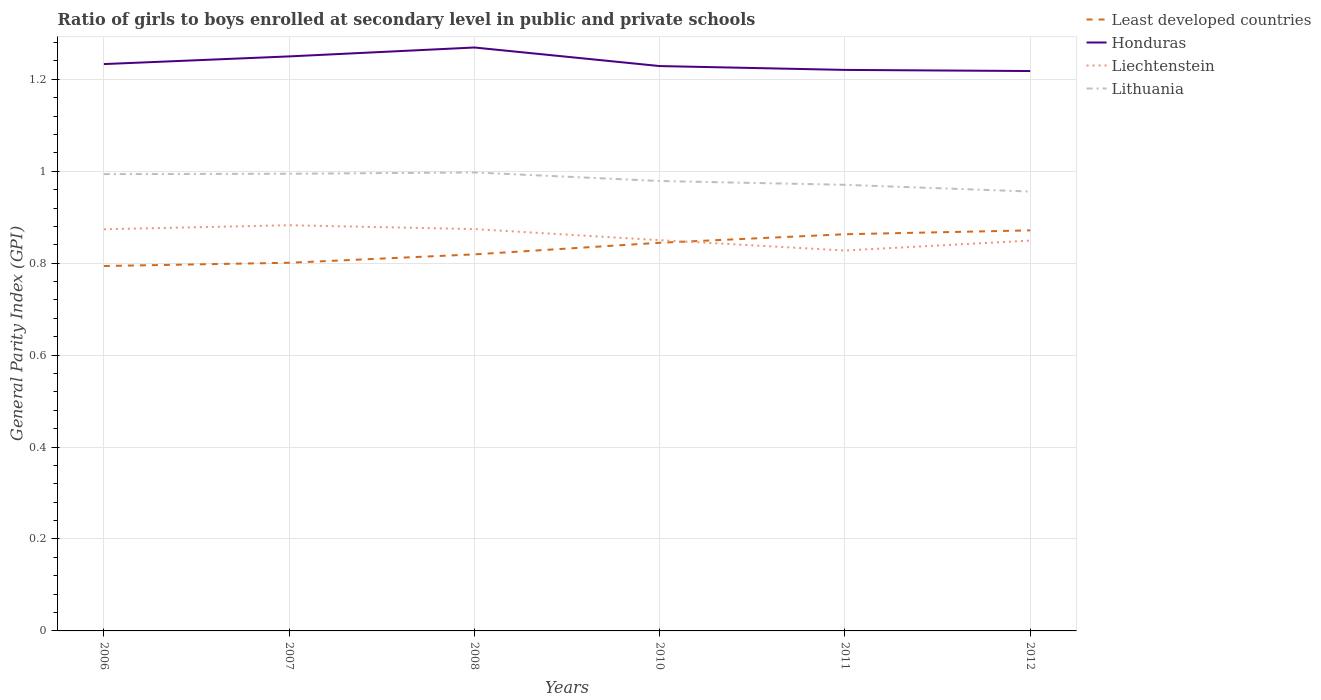How many different coloured lines are there?
Provide a short and direct response. 4. Does the line corresponding to Lithuania intersect with the line corresponding to Honduras?
Your answer should be compact. No. Is the number of lines equal to the number of legend labels?
Offer a terse response. Yes. Across all years, what is the maximum general parity index in Least developed countries?
Your answer should be very brief. 0.79. In which year was the general parity index in Least developed countries maximum?
Your answer should be compact. 2006. What is the total general parity index in Liechtenstein in the graph?
Your response must be concise. 0.02. What is the difference between the highest and the second highest general parity index in Least developed countries?
Provide a succinct answer. 0.08. What is the difference between the highest and the lowest general parity index in Lithuania?
Your answer should be compact. 3. Are the values on the major ticks of Y-axis written in scientific E-notation?
Your answer should be compact. No. Does the graph contain any zero values?
Provide a short and direct response. No. Does the graph contain grids?
Make the answer very short. Yes. Where does the legend appear in the graph?
Give a very brief answer. Top right. What is the title of the graph?
Offer a very short reply. Ratio of girls to boys enrolled at secondary level in public and private schools. Does "Turkmenistan" appear as one of the legend labels in the graph?
Offer a terse response. No. What is the label or title of the Y-axis?
Provide a short and direct response. General Parity Index (GPI). What is the General Parity Index (GPI) in Least developed countries in 2006?
Provide a short and direct response. 0.79. What is the General Parity Index (GPI) in Honduras in 2006?
Offer a terse response. 1.23. What is the General Parity Index (GPI) in Liechtenstein in 2006?
Keep it short and to the point. 0.87. What is the General Parity Index (GPI) in Lithuania in 2006?
Offer a terse response. 0.99. What is the General Parity Index (GPI) of Least developed countries in 2007?
Provide a succinct answer. 0.8. What is the General Parity Index (GPI) in Honduras in 2007?
Your answer should be very brief. 1.25. What is the General Parity Index (GPI) of Liechtenstein in 2007?
Give a very brief answer. 0.88. What is the General Parity Index (GPI) of Lithuania in 2007?
Ensure brevity in your answer.  0.99. What is the General Parity Index (GPI) in Least developed countries in 2008?
Ensure brevity in your answer.  0.82. What is the General Parity Index (GPI) in Honduras in 2008?
Your answer should be very brief. 1.27. What is the General Parity Index (GPI) of Liechtenstein in 2008?
Your response must be concise. 0.87. What is the General Parity Index (GPI) of Lithuania in 2008?
Offer a very short reply. 1. What is the General Parity Index (GPI) in Least developed countries in 2010?
Provide a succinct answer. 0.84. What is the General Parity Index (GPI) of Honduras in 2010?
Provide a succinct answer. 1.23. What is the General Parity Index (GPI) of Liechtenstein in 2010?
Give a very brief answer. 0.85. What is the General Parity Index (GPI) in Lithuania in 2010?
Keep it short and to the point. 0.98. What is the General Parity Index (GPI) in Least developed countries in 2011?
Keep it short and to the point. 0.86. What is the General Parity Index (GPI) in Honduras in 2011?
Give a very brief answer. 1.22. What is the General Parity Index (GPI) of Liechtenstein in 2011?
Your response must be concise. 0.83. What is the General Parity Index (GPI) in Lithuania in 2011?
Ensure brevity in your answer.  0.97. What is the General Parity Index (GPI) in Least developed countries in 2012?
Provide a short and direct response. 0.87. What is the General Parity Index (GPI) in Honduras in 2012?
Offer a very short reply. 1.22. What is the General Parity Index (GPI) of Liechtenstein in 2012?
Ensure brevity in your answer.  0.85. What is the General Parity Index (GPI) in Lithuania in 2012?
Give a very brief answer. 0.96. Across all years, what is the maximum General Parity Index (GPI) of Least developed countries?
Ensure brevity in your answer.  0.87. Across all years, what is the maximum General Parity Index (GPI) of Honduras?
Your answer should be very brief. 1.27. Across all years, what is the maximum General Parity Index (GPI) of Liechtenstein?
Give a very brief answer. 0.88. Across all years, what is the maximum General Parity Index (GPI) of Lithuania?
Give a very brief answer. 1. Across all years, what is the minimum General Parity Index (GPI) of Least developed countries?
Provide a succinct answer. 0.79. Across all years, what is the minimum General Parity Index (GPI) in Honduras?
Your response must be concise. 1.22. Across all years, what is the minimum General Parity Index (GPI) of Liechtenstein?
Provide a succinct answer. 0.83. Across all years, what is the minimum General Parity Index (GPI) of Lithuania?
Your answer should be compact. 0.96. What is the total General Parity Index (GPI) in Least developed countries in the graph?
Provide a succinct answer. 4.99. What is the total General Parity Index (GPI) in Honduras in the graph?
Your response must be concise. 7.42. What is the total General Parity Index (GPI) of Liechtenstein in the graph?
Your response must be concise. 5.16. What is the total General Parity Index (GPI) in Lithuania in the graph?
Your response must be concise. 5.89. What is the difference between the General Parity Index (GPI) in Least developed countries in 2006 and that in 2007?
Offer a very short reply. -0.01. What is the difference between the General Parity Index (GPI) in Honduras in 2006 and that in 2007?
Your answer should be compact. -0.02. What is the difference between the General Parity Index (GPI) of Liechtenstein in 2006 and that in 2007?
Your answer should be very brief. -0.01. What is the difference between the General Parity Index (GPI) in Lithuania in 2006 and that in 2007?
Make the answer very short. -0. What is the difference between the General Parity Index (GPI) of Least developed countries in 2006 and that in 2008?
Offer a very short reply. -0.03. What is the difference between the General Parity Index (GPI) of Honduras in 2006 and that in 2008?
Provide a succinct answer. -0.04. What is the difference between the General Parity Index (GPI) of Liechtenstein in 2006 and that in 2008?
Make the answer very short. -0. What is the difference between the General Parity Index (GPI) in Lithuania in 2006 and that in 2008?
Give a very brief answer. -0. What is the difference between the General Parity Index (GPI) of Least developed countries in 2006 and that in 2010?
Your answer should be compact. -0.05. What is the difference between the General Parity Index (GPI) of Honduras in 2006 and that in 2010?
Keep it short and to the point. 0. What is the difference between the General Parity Index (GPI) in Liechtenstein in 2006 and that in 2010?
Make the answer very short. 0.02. What is the difference between the General Parity Index (GPI) of Lithuania in 2006 and that in 2010?
Offer a very short reply. 0.01. What is the difference between the General Parity Index (GPI) of Least developed countries in 2006 and that in 2011?
Provide a succinct answer. -0.07. What is the difference between the General Parity Index (GPI) in Honduras in 2006 and that in 2011?
Your answer should be compact. 0.01. What is the difference between the General Parity Index (GPI) in Liechtenstein in 2006 and that in 2011?
Keep it short and to the point. 0.05. What is the difference between the General Parity Index (GPI) in Lithuania in 2006 and that in 2011?
Your answer should be very brief. 0.02. What is the difference between the General Parity Index (GPI) of Least developed countries in 2006 and that in 2012?
Give a very brief answer. -0.08. What is the difference between the General Parity Index (GPI) of Honduras in 2006 and that in 2012?
Provide a succinct answer. 0.02. What is the difference between the General Parity Index (GPI) of Liechtenstein in 2006 and that in 2012?
Provide a short and direct response. 0.02. What is the difference between the General Parity Index (GPI) of Lithuania in 2006 and that in 2012?
Provide a succinct answer. 0.04. What is the difference between the General Parity Index (GPI) of Least developed countries in 2007 and that in 2008?
Make the answer very short. -0.02. What is the difference between the General Parity Index (GPI) in Honduras in 2007 and that in 2008?
Make the answer very short. -0.02. What is the difference between the General Parity Index (GPI) in Liechtenstein in 2007 and that in 2008?
Your answer should be very brief. 0.01. What is the difference between the General Parity Index (GPI) in Lithuania in 2007 and that in 2008?
Provide a short and direct response. -0. What is the difference between the General Parity Index (GPI) in Least developed countries in 2007 and that in 2010?
Keep it short and to the point. -0.04. What is the difference between the General Parity Index (GPI) of Honduras in 2007 and that in 2010?
Your answer should be very brief. 0.02. What is the difference between the General Parity Index (GPI) in Liechtenstein in 2007 and that in 2010?
Your answer should be compact. 0.03. What is the difference between the General Parity Index (GPI) in Lithuania in 2007 and that in 2010?
Your answer should be compact. 0.02. What is the difference between the General Parity Index (GPI) in Least developed countries in 2007 and that in 2011?
Ensure brevity in your answer.  -0.06. What is the difference between the General Parity Index (GPI) in Honduras in 2007 and that in 2011?
Make the answer very short. 0.03. What is the difference between the General Parity Index (GPI) in Liechtenstein in 2007 and that in 2011?
Give a very brief answer. 0.06. What is the difference between the General Parity Index (GPI) in Lithuania in 2007 and that in 2011?
Your response must be concise. 0.02. What is the difference between the General Parity Index (GPI) in Least developed countries in 2007 and that in 2012?
Give a very brief answer. -0.07. What is the difference between the General Parity Index (GPI) of Honduras in 2007 and that in 2012?
Offer a very short reply. 0.03. What is the difference between the General Parity Index (GPI) of Liechtenstein in 2007 and that in 2012?
Make the answer very short. 0.03. What is the difference between the General Parity Index (GPI) in Lithuania in 2007 and that in 2012?
Offer a very short reply. 0.04. What is the difference between the General Parity Index (GPI) of Least developed countries in 2008 and that in 2010?
Ensure brevity in your answer.  -0.03. What is the difference between the General Parity Index (GPI) of Honduras in 2008 and that in 2010?
Ensure brevity in your answer.  0.04. What is the difference between the General Parity Index (GPI) in Liechtenstein in 2008 and that in 2010?
Ensure brevity in your answer.  0.02. What is the difference between the General Parity Index (GPI) in Lithuania in 2008 and that in 2010?
Your response must be concise. 0.02. What is the difference between the General Parity Index (GPI) of Least developed countries in 2008 and that in 2011?
Keep it short and to the point. -0.04. What is the difference between the General Parity Index (GPI) of Honduras in 2008 and that in 2011?
Make the answer very short. 0.05. What is the difference between the General Parity Index (GPI) of Liechtenstein in 2008 and that in 2011?
Ensure brevity in your answer.  0.05. What is the difference between the General Parity Index (GPI) in Lithuania in 2008 and that in 2011?
Provide a short and direct response. 0.03. What is the difference between the General Parity Index (GPI) of Least developed countries in 2008 and that in 2012?
Ensure brevity in your answer.  -0.05. What is the difference between the General Parity Index (GPI) in Honduras in 2008 and that in 2012?
Give a very brief answer. 0.05. What is the difference between the General Parity Index (GPI) in Liechtenstein in 2008 and that in 2012?
Your answer should be very brief. 0.03. What is the difference between the General Parity Index (GPI) in Lithuania in 2008 and that in 2012?
Your answer should be very brief. 0.04. What is the difference between the General Parity Index (GPI) of Least developed countries in 2010 and that in 2011?
Keep it short and to the point. -0.02. What is the difference between the General Parity Index (GPI) in Honduras in 2010 and that in 2011?
Provide a short and direct response. 0.01. What is the difference between the General Parity Index (GPI) of Liechtenstein in 2010 and that in 2011?
Offer a terse response. 0.02. What is the difference between the General Parity Index (GPI) of Lithuania in 2010 and that in 2011?
Provide a short and direct response. 0.01. What is the difference between the General Parity Index (GPI) of Least developed countries in 2010 and that in 2012?
Give a very brief answer. -0.03. What is the difference between the General Parity Index (GPI) in Honduras in 2010 and that in 2012?
Keep it short and to the point. 0.01. What is the difference between the General Parity Index (GPI) in Liechtenstein in 2010 and that in 2012?
Your answer should be compact. 0. What is the difference between the General Parity Index (GPI) in Lithuania in 2010 and that in 2012?
Ensure brevity in your answer.  0.02. What is the difference between the General Parity Index (GPI) in Least developed countries in 2011 and that in 2012?
Give a very brief answer. -0.01. What is the difference between the General Parity Index (GPI) in Honduras in 2011 and that in 2012?
Ensure brevity in your answer.  0. What is the difference between the General Parity Index (GPI) in Liechtenstein in 2011 and that in 2012?
Provide a succinct answer. -0.02. What is the difference between the General Parity Index (GPI) in Lithuania in 2011 and that in 2012?
Make the answer very short. 0.01. What is the difference between the General Parity Index (GPI) of Least developed countries in 2006 and the General Parity Index (GPI) of Honduras in 2007?
Ensure brevity in your answer.  -0.46. What is the difference between the General Parity Index (GPI) of Least developed countries in 2006 and the General Parity Index (GPI) of Liechtenstein in 2007?
Your response must be concise. -0.09. What is the difference between the General Parity Index (GPI) in Least developed countries in 2006 and the General Parity Index (GPI) in Lithuania in 2007?
Provide a short and direct response. -0.2. What is the difference between the General Parity Index (GPI) in Honduras in 2006 and the General Parity Index (GPI) in Liechtenstein in 2007?
Make the answer very short. 0.35. What is the difference between the General Parity Index (GPI) in Honduras in 2006 and the General Parity Index (GPI) in Lithuania in 2007?
Provide a short and direct response. 0.24. What is the difference between the General Parity Index (GPI) in Liechtenstein in 2006 and the General Parity Index (GPI) in Lithuania in 2007?
Offer a very short reply. -0.12. What is the difference between the General Parity Index (GPI) in Least developed countries in 2006 and the General Parity Index (GPI) in Honduras in 2008?
Provide a short and direct response. -0.48. What is the difference between the General Parity Index (GPI) of Least developed countries in 2006 and the General Parity Index (GPI) of Liechtenstein in 2008?
Your answer should be compact. -0.08. What is the difference between the General Parity Index (GPI) in Least developed countries in 2006 and the General Parity Index (GPI) in Lithuania in 2008?
Provide a short and direct response. -0.2. What is the difference between the General Parity Index (GPI) in Honduras in 2006 and the General Parity Index (GPI) in Liechtenstein in 2008?
Give a very brief answer. 0.36. What is the difference between the General Parity Index (GPI) in Honduras in 2006 and the General Parity Index (GPI) in Lithuania in 2008?
Make the answer very short. 0.24. What is the difference between the General Parity Index (GPI) in Liechtenstein in 2006 and the General Parity Index (GPI) in Lithuania in 2008?
Provide a succinct answer. -0.12. What is the difference between the General Parity Index (GPI) in Least developed countries in 2006 and the General Parity Index (GPI) in Honduras in 2010?
Offer a very short reply. -0.43. What is the difference between the General Parity Index (GPI) in Least developed countries in 2006 and the General Parity Index (GPI) in Liechtenstein in 2010?
Provide a succinct answer. -0.06. What is the difference between the General Parity Index (GPI) in Least developed countries in 2006 and the General Parity Index (GPI) in Lithuania in 2010?
Provide a short and direct response. -0.18. What is the difference between the General Parity Index (GPI) in Honduras in 2006 and the General Parity Index (GPI) in Liechtenstein in 2010?
Keep it short and to the point. 0.38. What is the difference between the General Parity Index (GPI) in Honduras in 2006 and the General Parity Index (GPI) in Lithuania in 2010?
Your answer should be compact. 0.25. What is the difference between the General Parity Index (GPI) in Liechtenstein in 2006 and the General Parity Index (GPI) in Lithuania in 2010?
Keep it short and to the point. -0.1. What is the difference between the General Parity Index (GPI) in Least developed countries in 2006 and the General Parity Index (GPI) in Honduras in 2011?
Your answer should be compact. -0.43. What is the difference between the General Parity Index (GPI) of Least developed countries in 2006 and the General Parity Index (GPI) of Liechtenstein in 2011?
Ensure brevity in your answer.  -0.03. What is the difference between the General Parity Index (GPI) in Least developed countries in 2006 and the General Parity Index (GPI) in Lithuania in 2011?
Make the answer very short. -0.18. What is the difference between the General Parity Index (GPI) in Honduras in 2006 and the General Parity Index (GPI) in Liechtenstein in 2011?
Your answer should be compact. 0.41. What is the difference between the General Parity Index (GPI) in Honduras in 2006 and the General Parity Index (GPI) in Lithuania in 2011?
Your response must be concise. 0.26. What is the difference between the General Parity Index (GPI) of Liechtenstein in 2006 and the General Parity Index (GPI) of Lithuania in 2011?
Provide a short and direct response. -0.1. What is the difference between the General Parity Index (GPI) of Least developed countries in 2006 and the General Parity Index (GPI) of Honduras in 2012?
Offer a very short reply. -0.42. What is the difference between the General Parity Index (GPI) of Least developed countries in 2006 and the General Parity Index (GPI) of Liechtenstein in 2012?
Provide a succinct answer. -0.06. What is the difference between the General Parity Index (GPI) of Least developed countries in 2006 and the General Parity Index (GPI) of Lithuania in 2012?
Your response must be concise. -0.16. What is the difference between the General Parity Index (GPI) in Honduras in 2006 and the General Parity Index (GPI) in Liechtenstein in 2012?
Your answer should be compact. 0.38. What is the difference between the General Parity Index (GPI) in Honduras in 2006 and the General Parity Index (GPI) in Lithuania in 2012?
Your answer should be compact. 0.28. What is the difference between the General Parity Index (GPI) in Liechtenstein in 2006 and the General Parity Index (GPI) in Lithuania in 2012?
Provide a short and direct response. -0.08. What is the difference between the General Parity Index (GPI) of Least developed countries in 2007 and the General Parity Index (GPI) of Honduras in 2008?
Make the answer very short. -0.47. What is the difference between the General Parity Index (GPI) of Least developed countries in 2007 and the General Parity Index (GPI) of Liechtenstein in 2008?
Give a very brief answer. -0.07. What is the difference between the General Parity Index (GPI) in Least developed countries in 2007 and the General Parity Index (GPI) in Lithuania in 2008?
Offer a very short reply. -0.2. What is the difference between the General Parity Index (GPI) in Honduras in 2007 and the General Parity Index (GPI) in Liechtenstein in 2008?
Your response must be concise. 0.38. What is the difference between the General Parity Index (GPI) in Honduras in 2007 and the General Parity Index (GPI) in Lithuania in 2008?
Make the answer very short. 0.25. What is the difference between the General Parity Index (GPI) in Liechtenstein in 2007 and the General Parity Index (GPI) in Lithuania in 2008?
Keep it short and to the point. -0.11. What is the difference between the General Parity Index (GPI) in Least developed countries in 2007 and the General Parity Index (GPI) in Honduras in 2010?
Your response must be concise. -0.43. What is the difference between the General Parity Index (GPI) of Least developed countries in 2007 and the General Parity Index (GPI) of Liechtenstein in 2010?
Provide a short and direct response. -0.05. What is the difference between the General Parity Index (GPI) of Least developed countries in 2007 and the General Parity Index (GPI) of Lithuania in 2010?
Keep it short and to the point. -0.18. What is the difference between the General Parity Index (GPI) of Honduras in 2007 and the General Parity Index (GPI) of Liechtenstein in 2010?
Your answer should be compact. 0.4. What is the difference between the General Parity Index (GPI) of Honduras in 2007 and the General Parity Index (GPI) of Lithuania in 2010?
Provide a short and direct response. 0.27. What is the difference between the General Parity Index (GPI) in Liechtenstein in 2007 and the General Parity Index (GPI) in Lithuania in 2010?
Offer a terse response. -0.1. What is the difference between the General Parity Index (GPI) of Least developed countries in 2007 and the General Parity Index (GPI) of Honduras in 2011?
Offer a very short reply. -0.42. What is the difference between the General Parity Index (GPI) of Least developed countries in 2007 and the General Parity Index (GPI) of Liechtenstein in 2011?
Ensure brevity in your answer.  -0.03. What is the difference between the General Parity Index (GPI) in Least developed countries in 2007 and the General Parity Index (GPI) in Lithuania in 2011?
Offer a very short reply. -0.17. What is the difference between the General Parity Index (GPI) of Honduras in 2007 and the General Parity Index (GPI) of Liechtenstein in 2011?
Your answer should be very brief. 0.42. What is the difference between the General Parity Index (GPI) of Honduras in 2007 and the General Parity Index (GPI) of Lithuania in 2011?
Keep it short and to the point. 0.28. What is the difference between the General Parity Index (GPI) of Liechtenstein in 2007 and the General Parity Index (GPI) of Lithuania in 2011?
Provide a succinct answer. -0.09. What is the difference between the General Parity Index (GPI) in Least developed countries in 2007 and the General Parity Index (GPI) in Honduras in 2012?
Ensure brevity in your answer.  -0.42. What is the difference between the General Parity Index (GPI) in Least developed countries in 2007 and the General Parity Index (GPI) in Liechtenstein in 2012?
Give a very brief answer. -0.05. What is the difference between the General Parity Index (GPI) of Least developed countries in 2007 and the General Parity Index (GPI) of Lithuania in 2012?
Keep it short and to the point. -0.15. What is the difference between the General Parity Index (GPI) in Honduras in 2007 and the General Parity Index (GPI) in Liechtenstein in 2012?
Ensure brevity in your answer.  0.4. What is the difference between the General Parity Index (GPI) of Honduras in 2007 and the General Parity Index (GPI) of Lithuania in 2012?
Make the answer very short. 0.29. What is the difference between the General Parity Index (GPI) of Liechtenstein in 2007 and the General Parity Index (GPI) of Lithuania in 2012?
Ensure brevity in your answer.  -0.07. What is the difference between the General Parity Index (GPI) in Least developed countries in 2008 and the General Parity Index (GPI) in Honduras in 2010?
Keep it short and to the point. -0.41. What is the difference between the General Parity Index (GPI) of Least developed countries in 2008 and the General Parity Index (GPI) of Liechtenstein in 2010?
Your response must be concise. -0.03. What is the difference between the General Parity Index (GPI) of Least developed countries in 2008 and the General Parity Index (GPI) of Lithuania in 2010?
Give a very brief answer. -0.16. What is the difference between the General Parity Index (GPI) in Honduras in 2008 and the General Parity Index (GPI) in Liechtenstein in 2010?
Your response must be concise. 0.42. What is the difference between the General Parity Index (GPI) of Honduras in 2008 and the General Parity Index (GPI) of Lithuania in 2010?
Your response must be concise. 0.29. What is the difference between the General Parity Index (GPI) of Liechtenstein in 2008 and the General Parity Index (GPI) of Lithuania in 2010?
Keep it short and to the point. -0.1. What is the difference between the General Parity Index (GPI) in Least developed countries in 2008 and the General Parity Index (GPI) in Honduras in 2011?
Offer a terse response. -0.4. What is the difference between the General Parity Index (GPI) in Least developed countries in 2008 and the General Parity Index (GPI) in Liechtenstein in 2011?
Provide a short and direct response. -0.01. What is the difference between the General Parity Index (GPI) in Least developed countries in 2008 and the General Parity Index (GPI) in Lithuania in 2011?
Provide a succinct answer. -0.15. What is the difference between the General Parity Index (GPI) of Honduras in 2008 and the General Parity Index (GPI) of Liechtenstein in 2011?
Offer a terse response. 0.44. What is the difference between the General Parity Index (GPI) of Honduras in 2008 and the General Parity Index (GPI) of Lithuania in 2011?
Give a very brief answer. 0.3. What is the difference between the General Parity Index (GPI) of Liechtenstein in 2008 and the General Parity Index (GPI) of Lithuania in 2011?
Your answer should be very brief. -0.1. What is the difference between the General Parity Index (GPI) in Least developed countries in 2008 and the General Parity Index (GPI) in Honduras in 2012?
Offer a very short reply. -0.4. What is the difference between the General Parity Index (GPI) in Least developed countries in 2008 and the General Parity Index (GPI) in Liechtenstein in 2012?
Keep it short and to the point. -0.03. What is the difference between the General Parity Index (GPI) of Least developed countries in 2008 and the General Parity Index (GPI) of Lithuania in 2012?
Provide a short and direct response. -0.14. What is the difference between the General Parity Index (GPI) in Honduras in 2008 and the General Parity Index (GPI) in Liechtenstein in 2012?
Ensure brevity in your answer.  0.42. What is the difference between the General Parity Index (GPI) in Honduras in 2008 and the General Parity Index (GPI) in Lithuania in 2012?
Provide a short and direct response. 0.31. What is the difference between the General Parity Index (GPI) of Liechtenstein in 2008 and the General Parity Index (GPI) of Lithuania in 2012?
Keep it short and to the point. -0.08. What is the difference between the General Parity Index (GPI) in Least developed countries in 2010 and the General Parity Index (GPI) in Honduras in 2011?
Your answer should be compact. -0.38. What is the difference between the General Parity Index (GPI) of Least developed countries in 2010 and the General Parity Index (GPI) of Liechtenstein in 2011?
Your answer should be very brief. 0.02. What is the difference between the General Parity Index (GPI) of Least developed countries in 2010 and the General Parity Index (GPI) of Lithuania in 2011?
Offer a terse response. -0.13. What is the difference between the General Parity Index (GPI) of Honduras in 2010 and the General Parity Index (GPI) of Liechtenstein in 2011?
Ensure brevity in your answer.  0.4. What is the difference between the General Parity Index (GPI) in Honduras in 2010 and the General Parity Index (GPI) in Lithuania in 2011?
Your answer should be very brief. 0.26. What is the difference between the General Parity Index (GPI) of Liechtenstein in 2010 and the General Parity Index (GPI) of Lithuania in 2011?
Make the answer very short. -0.12. What is the difference between the General Parity Index (GPI) of Least developed countries in 2010 and the General Parity Index (GPI) of Honduras in 2012?
Your answer should be compact. -0.37. What is the difference between the General Parity Index (GPI) in Least developed countries in 2010 and the General Parity Index (GPI) in Liechtenstein in 2012?
Make the answer very short. -0. What is the difference between the General Parity Index (GPI) of Least developed countries in 2010 and the General Parity Index (GPI) of Lithuania in 2012?
Provide a succinct answer. -0.11. What is the difference between the General Parity Index (GPI) of Honduras in 2010 and the General Parity Index (GPI) of Liechtenstein in 2012?
Offer a very short reply. 0.38. What is the difference between the General Parity Index (GPI) of Honduras in 2010 and the General Parity Index (GPI) of Lithuania in 2012?
Offer a very short reply. 0.27. What is the difference between the General Parity Index (GPI) of Liechtenstein in 2010 and the General Parity Index (GPI) of Lithuania in 2012?
Your answer should be compact. -0.11. What is the difference between the General Parity Index (GPI) of Least developed countries in 2011 and the General Parity Index (GPI) of Honduras in 2012?
Your response must be concise. -0.36. What is the difference between the General Parity Index (GPI) of Least developed countries in 2011 and the General Parity Index (GPI) of Liechtenstein in 2012?
Your answer should be compact. 0.01. What is the difference between the General Parity Index (GPI) of Least developed countries in 2011 and the General Parity Index (GPI) of Lithuania in 2012?
Your response must be concise. -0.09. What is the difference between the General Parity Index (GPI) in Honduras in 2011 and the General Parity Index (GPI) in Liechtenstein in 2012?
Provide a succinct answer. 0.37. What is the difference between the General Parity Index (GPI) of Honduras in 2011 and the General Parity Index (GPI) of Lithuania in 2012?
Make the answer very short. 0.26. What is the difference between the General Parity Index (GPI) of Liechtenstein in 2011 and the General Parity Index (GPI) of Lithuania in 2012?
Ensure brevity in your answer.  -0.13. What is the average General Parity Index (GPI) of Least developed countries per year?
Your answer should be very brief. 0.83. What is the average General Parity Index (GPI) in Honduras per year?
Your answer should be very brief. 1.24. What is the average General Parity Index (GPI) in Liechtenstein per year?
Make the answer very short. 0.86. What is the average General Parity Index (GPI) of Lithuania per year?
Ensure brevity in your answer.  0.98. In the year 2006, what is the difference between the General Parity Index (GPI) in Least developed countries and General Parity Index (GPI) in Honduras?
Ensure brevity in your answer.  -0.44. In the year 2006, what is the difference between the General Parity Index (GPI) of Least developed countries and General Parity Index (GPI) of Liechtenstein?
Your answer should be compact. -0.08. In the year 2006, what is the difference between the General Parity Index (GPI) in Least developed countries and General Parity Index (GPI) in Lithuania?
Offer a very short reply. -0.2. In the year 2006, what is the difference between the General Parity Index (GPI) of Honduras and General Parity Index (GPI) of Liechtenstein?
Your answer should be compact. 0.36. In the year 2006, what is the difference between the General Parity Index (GPI) in Honduras and General Parity Index (GPI) in Lithuania?
Offer a terse response. 0.24. In the year 2006, what is the difference between the General Parity Index (GPI) of Liechtenstein and General Parity Index (GPI) of Lithuania?
Make the answer very short. -0.12. In the year 2007, what is the difference between the General Parity Index (GPI) of Least developed countries and General Parity Index (GPI) of Honduras?
Provide a short and direct response. -0.45. In the year 2007, what is the difference between the General Parity Index (GPI) of Least developed countries and General Parity Index (GPI) of Liechtenstein?
Make the answer very short. -0.08. In the year 2007, what is the difference between the General Parity Index (GPI) of Least developed countries and General Parity Index (GPI) of Lithuania?
Ensure brevity in your answer.  -0.19. In the year 2007, what is the difference between the General Parity Index (GPI) in Honduras and General Parity Index (GPI) in Liechtenstein?
Offer a terse response. 0.37. In the year 2007, what is the difference between the General Parity Index (GPI) in Honduras and General Parity Index (GPI) in Lithuania?
Ensure brevity in your answer.  0.26. In the year 2007, what is the difference between the General Parity Index (GPI) in Liechtenstein and General Parity Index (GPI) in Lithuania?
Your answer should be compact. -0.11. In the year 2008, what is the difference between the General Parity Index (GPI) in Least developed countries and General Parity Index (GPI) in Honduras?
Provide a succinct answer. -0.45. In the year 2008, what is the difference between the General Parity Index (GPI) of Least developed countries and General Parity Index (GPI) of Liechtenstein?
Offer a very short reply. -0.06. In the year 2008, what is the difference between the General Parity Index (GPI) in Least developed countries and General Parity Index (GPI) in Lithuania?
Provide a succinct answer. -0.18. In the year 2008, what is the difference between the General Parity Index (GPI) of Honduras and General Parity Index (GPI) of Liechtenstein?
Give a very brief answer. 0.4. In the year 2008, what is the difference between the General Parity Index (GPI) of Honduras and General Parity Index (GPI) of Lithuania?
Ensure brevity in your answer.  0.27. In the year 2008, what is the difference between the General Parity Index (GPI) in Liechtenstein and General Parity Index (GPI) in Lithuania?
Ensure brevity in your answer.  -0.12. In the year 2010, what is the difference between the General Parity Index (GPI) of Least developed countries and General Parity Index (GPI) of Honduras?
Offer a very short reply. -0.38. In the year 2010, what is the difference between the General Parity Index (GPI) in Least developed countries and General Parity Index (GPI) in Liechtenstein?
Offer a very short reply. -0.01. In the year 2010, what is the difference between the General Parity Index (GPI) of Least developed countries and General Parity Index (GPI) of Lithuania?
Your answer should be compact. -0.13. In the year 2010, what is the difference between the General Parity Index (GPI) of Honduras and General Parity Index (GPI) of Liechtenstein?
Your answer should be very brief. 0.38. In the year 2010, what is the difference between the General Parity Index (GPI) of Honduras and General Parity Index (GPI) of Lithuania?
Offer a terse response. 0.25. In the year 2010, what is the difference between the General Parity Index (GPI) in Liechtenstein and General Parity Index (GPI) in Lithuania?
Offer a very short reply. -0.13. In the year 2011, what is the difference between the General Parity Index (GPI) of Least developed countries and General Parity Index (GPI) of Honduras?
Provide a succinct answer. -0.36. In the year 2011, what is the difference between the General Parity Index (GPI) of Least developed countries and General Parity Index (GPI) of Liechtenstein?
Give a very brief answer. 0.04. In the year 2011, what is the difference between the General Parity Index (GPI) of Least developed countries and General Parity Index (GPI) of Lithuania?
Offer a terse response. -0.11. In the year 2011, what is the difference between the General Parity Index (GPI) of Honduras and General Parity Index (GPI) of Liechtenstein?
Your response must be concise. 0.39. In the year 2011, what is the difference between the General Parity Index (GPI) in Liechtenstein and General Parity Index (GPI) in Lithuania?
Make the answer very short. -0.14. In the year 2012, what is the difference between the General Parity Index (GPI) in Least developed countries and General Parity Index (GPI) in Honduras?
Ensure brevity in your answer.  -0.35. In the year 2012, what is the difference between the General Parity Index (GPI) of Least developed countries and General Parity Index (GPI) of Liechtenstein?
Ensure brevity in your answer.  0.02. In the year 2012, what is the difference between the General Parity Index (GPI) in Least developed countries and General Parity Index (GPI) in Lithuania?
Provide a short and direct response. -0.08. In the year 2012, what is the difference between the General Parity Index (GPI) in Honduras and General Parity Index (GPI) in Liechtenstein?
Offer a terse response. 0.37. In the year 2012, what is the difference between the General Parity Index (GPI) in Honduras and General Parity Index (GPI) in Lithuania?
Your answer should be compact. 0.26. In the year 2012, what is the difference between the General Parity Index (GPI) of Liechtenstein and General Parity Index (GPI) of Lithuania?
Your answer should be very brief. -0.11. What is the ratio of the General Parity Index (GPI) of Honduras in 2006 to that in 2007?
Your response must be concise. 0.99. What is the ratio of the General Parity Index (GPI) in Least developed countries in 2006 to that in 2008?
Ensure brevity in your answer.  0.97. What is the ratio of the General Parity Index (GPI) in Honduras in 2006 to that in 2008?
Provide a succinct answer. 0.97. What is the ratio of the General Parity Index (GPI) in Liechtenstein in 2006 to that in 2008?
Offer a very short reply. 1. What is the ratio of the General Parity Index (GPI) of Lithuania in 2006 to that in 2008?
Ensure brevity in your answer.  1. What is the ratio of the General Parity Index (GPI) of Least developed countries in 2006 to that in 2010?
Your response must be concise. 0.94. What is the ratio of the General Parity Index (GPI) of Honduras in 2006 to that in 2010?
Your answer should be very brief. 1. What is the ratio of the General Parity Index (GPI) in Liechtenstein in 2006 to that in 2010?
Ensure brevity in your answer.  1.03. What is the ratio of the General Parity Index (GPI) in Lithuania in 2006 to that in 2010?
Offer a terse response. 1.02. What is the ratio of the General Parity Index (GPI) of Least developed countries in 2006 to that in 2011?
Offer a very short reply. 0.92. What is the ratio of the General Parity Index (GPI) in Honduras in 2006 to that in 2011?
Ensure brevity in your answer.  1.01. What is the ratio of the General Parity Index (GPI) in Liechtenstein in 2006 to that in 2011?
Make the answer very short. 1.06. What is the ratio of the General Parity Index (GPI) in Lithuania in 2006 to that in 2011?
Make the answer very short. 1.02. What is the ratio of the General Parity Index (GPI) of Least developed countries in 2006 to that in 2012?
Provide a succinct answer. 0.91. What is the ratio of the General Parity Index (GPI) in Honduras in 2006 to that in 2012?
Ensure brevity in your answer.  1.01. What is the ratio of the General Parity Index (GPI) of Liechtenstein in 2006 to that in 2012?
Keep it short and to the point. 1.03. What is the ratio of the General Parity Index (GPI) of Lithuania in 2006 to that in 2012?
Provide a short and direct response. 1.04. What is the ratio of the General Parity Index (GPI) in Least developed countries in 2007 to that in 2008?
Offer a terse response. 0.98. What is the ratio of the General Parity Index (GPI) in Honduras in 2007 to that in 2008?
Keep it short and to the point. 0.98. What is the ratio of the General Parity Index (GPI) in Liechtenstein in 2007 to that in 2008?
Ensure brevity in your answer.  1.01. What is the ratio of the General Parity Index (GPI) in Lithuania in 2007 to that in 2008?
Provide a succinct answer. 1. What is the ratio of the General Parity Index (GPI) of Least developed countries in 2007 to that in 2010?
Your answer should be compact. 0.95. What is the ratio of the General Parity Index (GPI) of Honduras in 2007 to that in 2010?
Your answer should be very brief. 1.02. What is the ratio of the General Parity Index (GPI) in Liechtenstein in 2007 to that in 2010?
Offer a terse response. 1.04. What is the ratio of the General Parity Index (GPI) of Lithuania in 2007 to that in 2010?
Offer a terse response. 1.02. What is the ratio of the General Parity Index (GPI) in Least developed countries in 2007 to that in 2011?
Give a very brief answer. 0.93. What is the ratio of the General Parity Index (GPI) in Honduras in 2007 to that in 2011?
Offer a terse response. 1.02. What is the ratio of the General Parity Index (GPI) of Liechtenstein in 2007 to that in 2011?
Provide a short and direct response. 1.07. What is the ratio of the General Parity Index (GPI) in Lithuania in 2007 to that in 2011?
Provide a short and direct response. 1.02. What is the ratio of the General Parity Index (GPI) in Least developed countries in 2007 to that in 2012?
Offer a very short reply. 0.92. What is the ratio of the General Parity Index (GPI) of Honduras in 2007 to that in 2012?
Offer a terse response. 1.03. What is the ratio of the General Parity Index (GPI) in Liechtenstein in 2007 to that in 2012?
Your answer should be compact. 1.04. What is the ratio of the General Parity Index (GPI) of Lithuania in 2007 to that in 2012?
Your answer should be compact. 1.04. What is the ratio of the General Parity Index (GPI) of Least developed countries in 2008 to that in 2010?
Ensure brevity in your answer.  0.97. What is the ratio of the General Parity Index (GPI) in Honduras in 2008 to that in 2010?
Ensure brevity in your answer.  1.03. What is the ratio of the General Parity Index (GPI) in Liechtenstein in 2008 to that in 2010?
Offer a terse response. 1.03. What is the ratio of the General Parity Index (GPI) of Least developed countries in 2008 to that in 2011?
Give a very brief answer. 0.95. What is the ratio of the General Parity Index (GPI) of Honduras in 2008 to that in 2011?
Offer a terse response. 1.04. What is the ratio of the General Parity Index (GPI) of Liechtenstein in 2008 to that in 2011?
Keep it short and to the point. 1.06. What is the ratio of the General Parity Index (GPI) of Lithuania in 2008 to that in 2011?
Offer a terse response. 1.03. What is the ratio of the General Parity Index (GPI) of Least developed countries in 2008 to that in 2012?
Make the answer very short. 0.94. What is the ratio of the General Parity Index (GPI) in Honduras in 2008 to that in 2012?
Your answer should be very brief. 1.04. What is the ratio of the General Parity Index (GPI) in Liechtenstein in 2008 to that in 2012?
Make the answer very short. 1.03. What is the ratio of the General Parity Index (GPI) of Lithuania in 2008 to that in 2012?
Offer a terse response. 1.04. What is the ratio of the General Parity Index (GPI) in Least developed countries in 2010 to that in 2011?
Give a very brief answer. 0.98. What is the ratio of the General Parity Index (GPI) of Honduras in 2010 to that in 2011?
Provide a short and direct response. 1.01. What is the ratio of the General Parity Index (GPI) in Liechtenstein in 2010 to that in 2011?
Offer a terse response. 1.03. What is the ratio of the General Parity Index (GPI) of Lithuania in 2010 to that in 2011?
Your answer should be compact. 1.01. What is the ratio of the General Parity Index (GPI) in Honduras in 2010 to that in 2012?
Your answer should be compact. 1.01. What is the ratio of the General Parity Index (GPI) in Lithuania in 2010 to that in 2012?
Give a very brief answer. 1.02. What is the ratio of the General Parity Index (GPI) in Least developed countries in 2011 to that in 2012?
Offer a very short reply. 0.99. What is the ratio of the General Parity Index (GPI) of Honduras in 2011 to that in 2012?
Offer a very short reply. 1. What is the ratio of the General Parity Index (GPI) in Liechtenstein in 2011 to that in 2012?
Your answer should be very brief. 0.97. What is the ratio of the General Parity Index (GPI) in Lithuania in 2011 to that in 2012?
Give a very brief answer. 1.02. What is the difference between the highest and the second highest General Parity Index (GPI) in Least developed countries?
Offer a very short reply. 0.01. What is the difference between the highest and the second highest General Parity Index (GPI) of Honduras?
Keep it short and to the point. 0.02. What is the difference between the highest and the second highest General Parity Index (GPI) in Liechtenstein?
Offer a very short reply. 0.01. What is the difference between the highest and the second highest General Parity Index (GPI) in Lithuania?
Provide a short and direct response. 0. What is the difference between the highest and the lowest General Parity Index (GPI) in Least developed countries?
Offer a terse response. 0.08. What is the difference between the highest and the lowest General Parity Index (GPI) of Honduras?
Your answer should be very brief. 0.05. What is the difference between the highest and the lowest General Parity Index (GPI) in Liechtenstein?
Your response must be concise. 0.06. What is the difference between the highest and the lowest General Parity Index (GPI) in Lithuania?
Your answer should be compact. 0.04. 